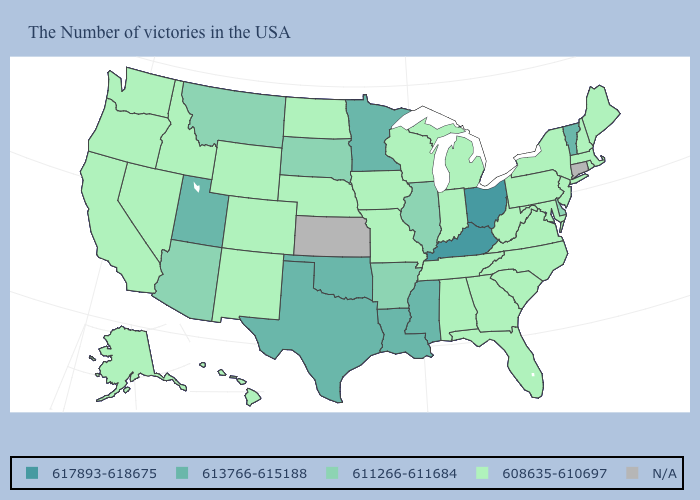Which states have the highest value in the USA?
Give a very brief answer. Ohio, Kentucky. What is the value of New Mexico?
Quick response, please. 608635-610697. Among the states that border New York , which have the lowest value?
Be succinct. Massachusetts, New Jersey, Pennsylvania. Which states have the lowest value in the USA?
Short answer required. Maine, Massachusetts, Rhode Island, New Hampshire, New York, New Jersey, Maryland, Pennsylvania, Virginia, North Carolina, South Carolina, West Virginia, Florida, Georgia, Michigan, Indiana, Alabama, Tennessee, Wisconsin, Missouri, Iowa, Nebraska, North Dakota, Wyoming, Colorado, New Mexico, Idaho, Nevada, California, Washington, Oregon, Alaska, Hawaii. Name the states that have a value in the range 611266-611684?
Concise answer only. Delaware, Illinois, Arkansas, South Dakota, Montana, Arizona. Name the states that have a value in the range N/A?
Short answer required. Connecticut, Kansas. What is the lowest value in states that border Vermont?
Give a very brief answer. 608635-610697. Name the states that have a value in the range 611266-611684?
Short answer required. Delaware, Illinois, Arkansas, South Dakota, Montana, Arizona. Name the states that have a value in the range 611266-611684?
Write a very short answer. Delaware, Illinois, Arkansas, South Dakota, Montana, Arizona. What is the value of New Mexico?
Answer briefly. 608635-610697. Name the states that have a value in the range 608635-610697?
Write a very short answer. Maine, Massachusetts, Rhode Island, New Hampshire, New York, New Jersey, Maryland, Pennsylvania, Virginia, North Carolina, South Carolina, West Virginia, Florida, Georgia, Michigan, Indiana, Alabama, Tennessee, Wisconsin, Missouri, Iowa, Nebraska, North Dakota, Wyoming, Colorado, New Mexico, Idaho, Nevada, California, Washington, Oregon, Alaska, Hawaii. Name the states that have a value in the range N/A?
Give a very brief answer. Connecticut, Kansas. Does Ohio have the highest value in the USA?
Concise answer only. Yes. Name the states that have a value in the range 617893-618675?
Short answer required. Ohio, Kentucky. 